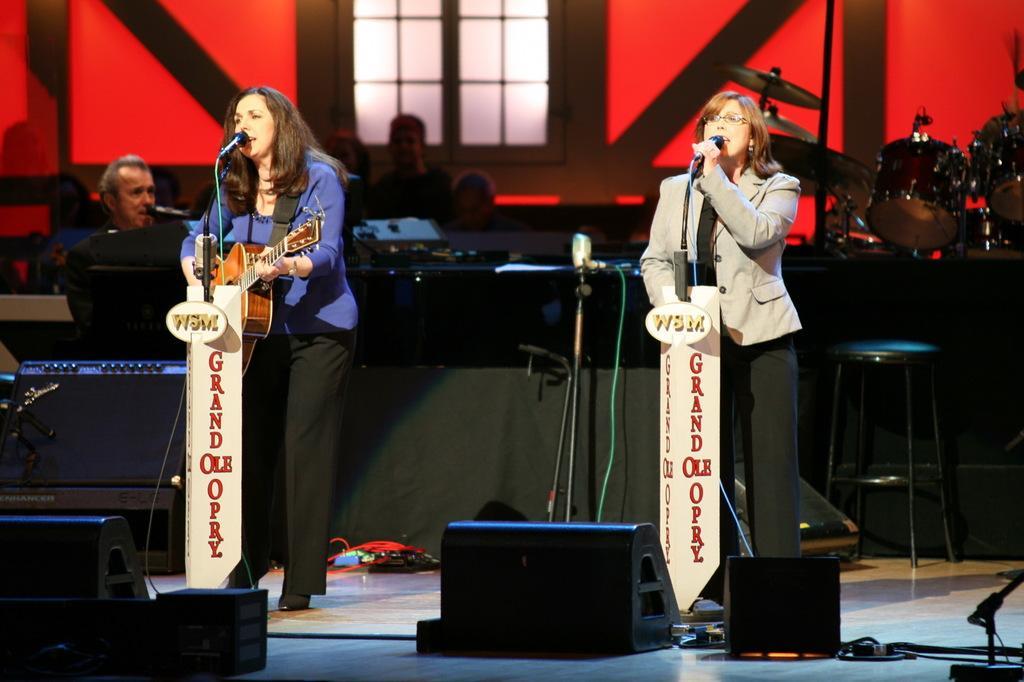Please provide a concise description of this image. In this image we can see a group of people. On the right side the woman is singing and holding a mic. On the left side the woman is playing a guitar. 